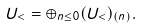<formula> <loc_0><loc_0><loc_500><loc_500>U _ { < } = \oplus _ { n \leq 0 } ( U _ { < } ) _ { ( n ) } .</formula> 